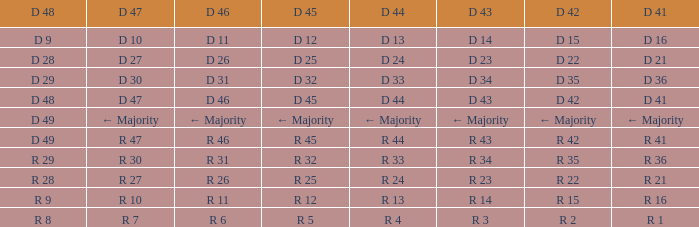Name the D 47 when it has a D 45 of d 32 D 30. 